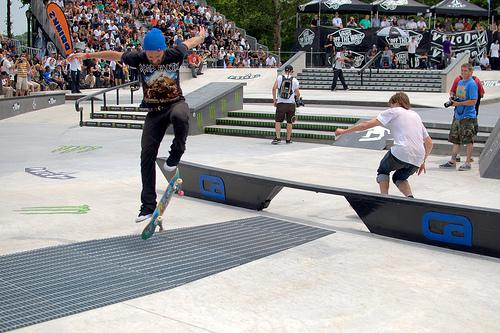Question: what kind of trick is the man in the front trying to do?
Choices:
A. Spin the basketball on his finger.
B. Bounce the golf ball off his golf club.
C. Flipping the skateboard and land right back on it.
D. Slid his skateboard down the rail.
Answer with the letter. Answer: C Question: where is this happening?
Choices:
A. Inside a church.
B. Inside a school.
C. Inside a stadium.
D. Inside a hospital.
Answer with the letter. Answer: C Question: what is the color of the hat of the man in the front?
Choices:
A. Black.
B. Blue.
C. Red.
D. White.
Answer with the letter. Answer: B 